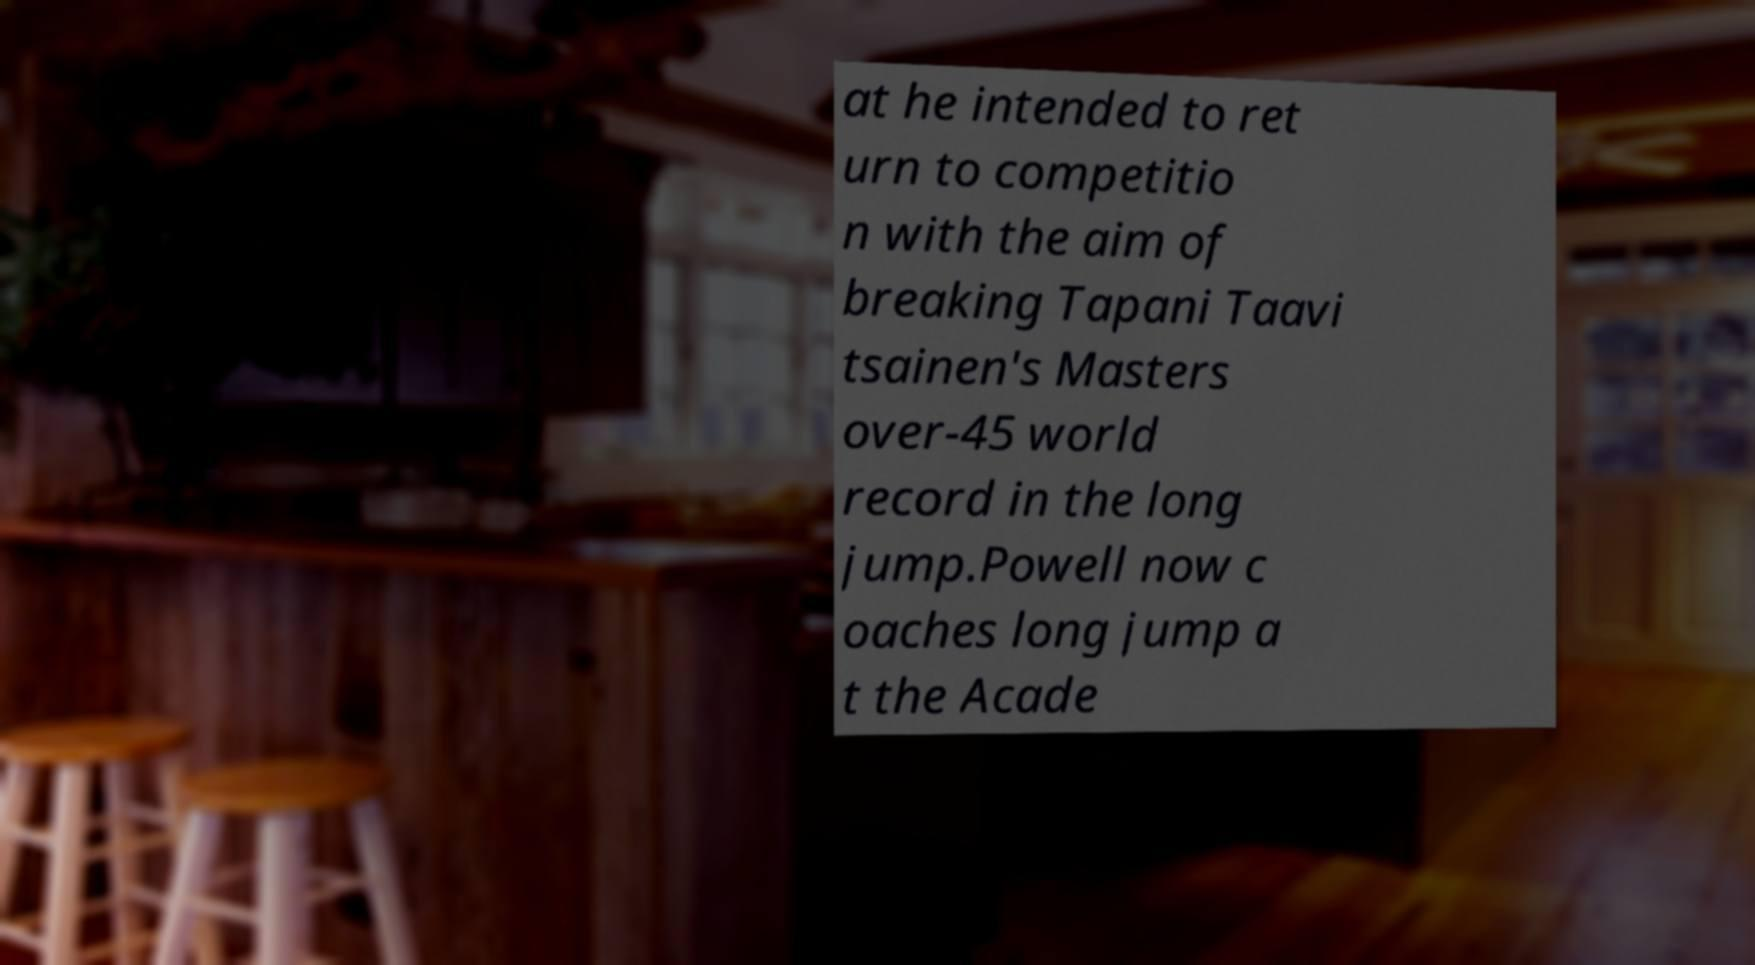I need the written content from this picture converted into text. Can you do that? at he intended to ret urn to competitio n with the aim of breaking Tapani Taavi tsainen's Masters over-45 world record in the long jump.Powell now c oaches long jump a t the Acade 